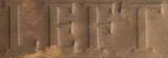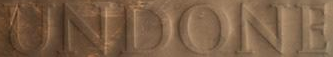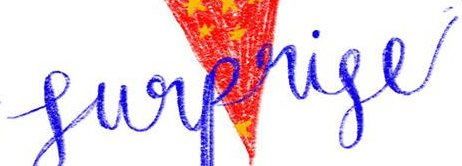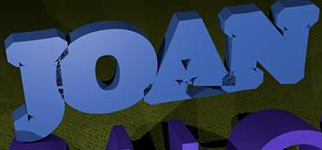Identify the words shown in these images in order, separated by a semicolon. LEFT; UNDONE; Surprise; JOAN 